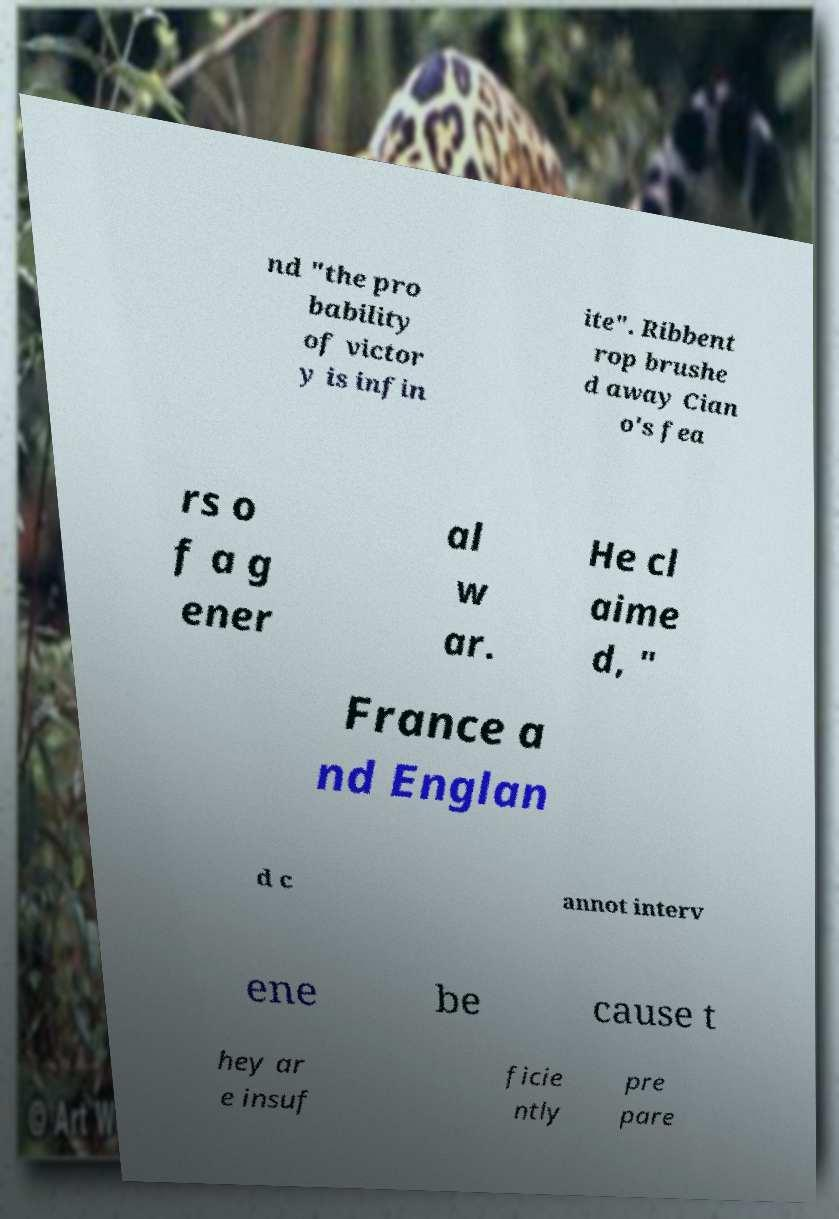Could you extract and type out the text from this image? nd "the pro bability of victor y is infin ite". Ribbent rop brushe d away Cian o's fea rs o f a g ener al w ar. He cl aime d, " France a nd Englan d c annot interv ene be cause t hey ar e insuf ficie ntly pre pare 